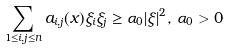<formula> <loc_0><loc_0><loc_500><loc_500>\sum _ { 1 \leq i , j \leq n } a _ { i , j } ( x ) \xi _ { i } \xi _ { j } \geq \alpha _ { 0 } | \xi | ^ { 2 } , \, \alpha _ { 0 } > 0</formula> 